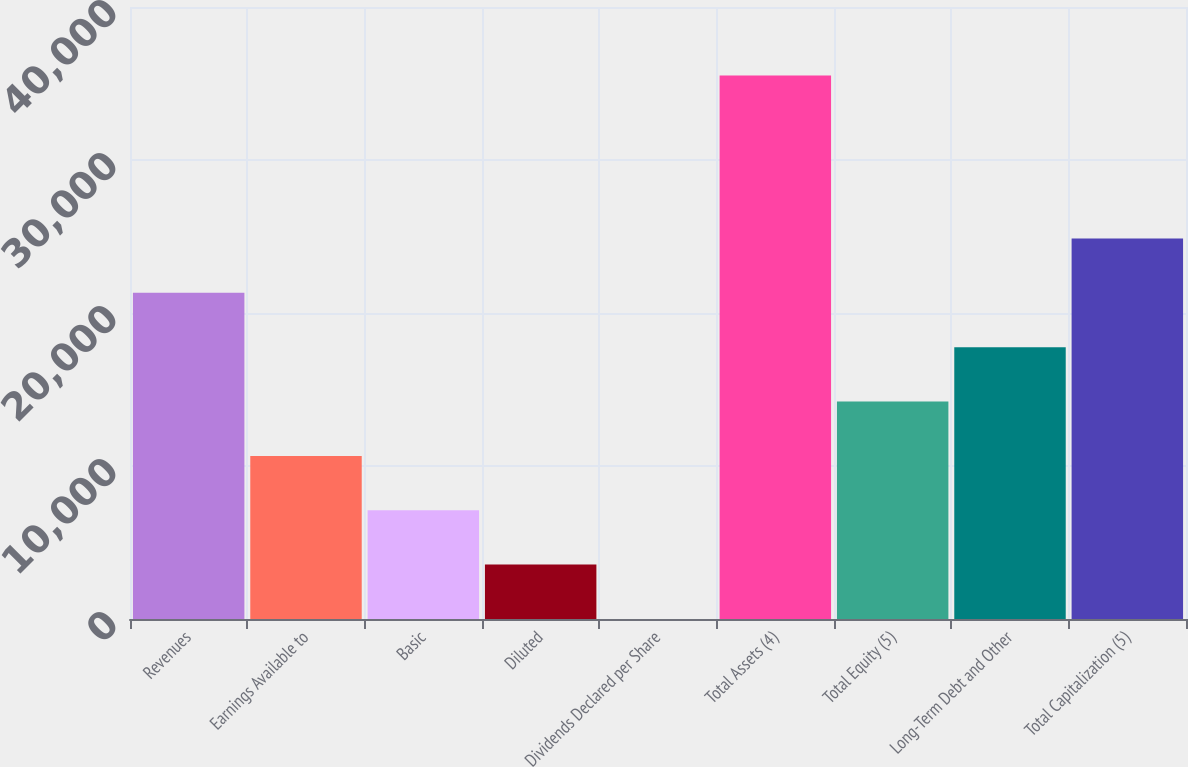Convert chart. <chart><loc_0><loc_0><loc_500><loc_500><bar_chart><fcel>Revenues<fcel>Earnings Available to<fcel>Basic<fcel>Diluted<fcel>Dividends Declared per Share<fcel>Total Assets (4)<fcel>Total Equity (5)<fcel>Long-Term Debt and Other<fcel>Total Capitalization (5)<nl><fcel>21319.5<fcel>10660.8<fcel>7107.96<fcel>3555.08<fcel>2.2<fcel>35531<fcel>14213.7<fcel>17766.6<fcel>24872.4<nl></chart> 